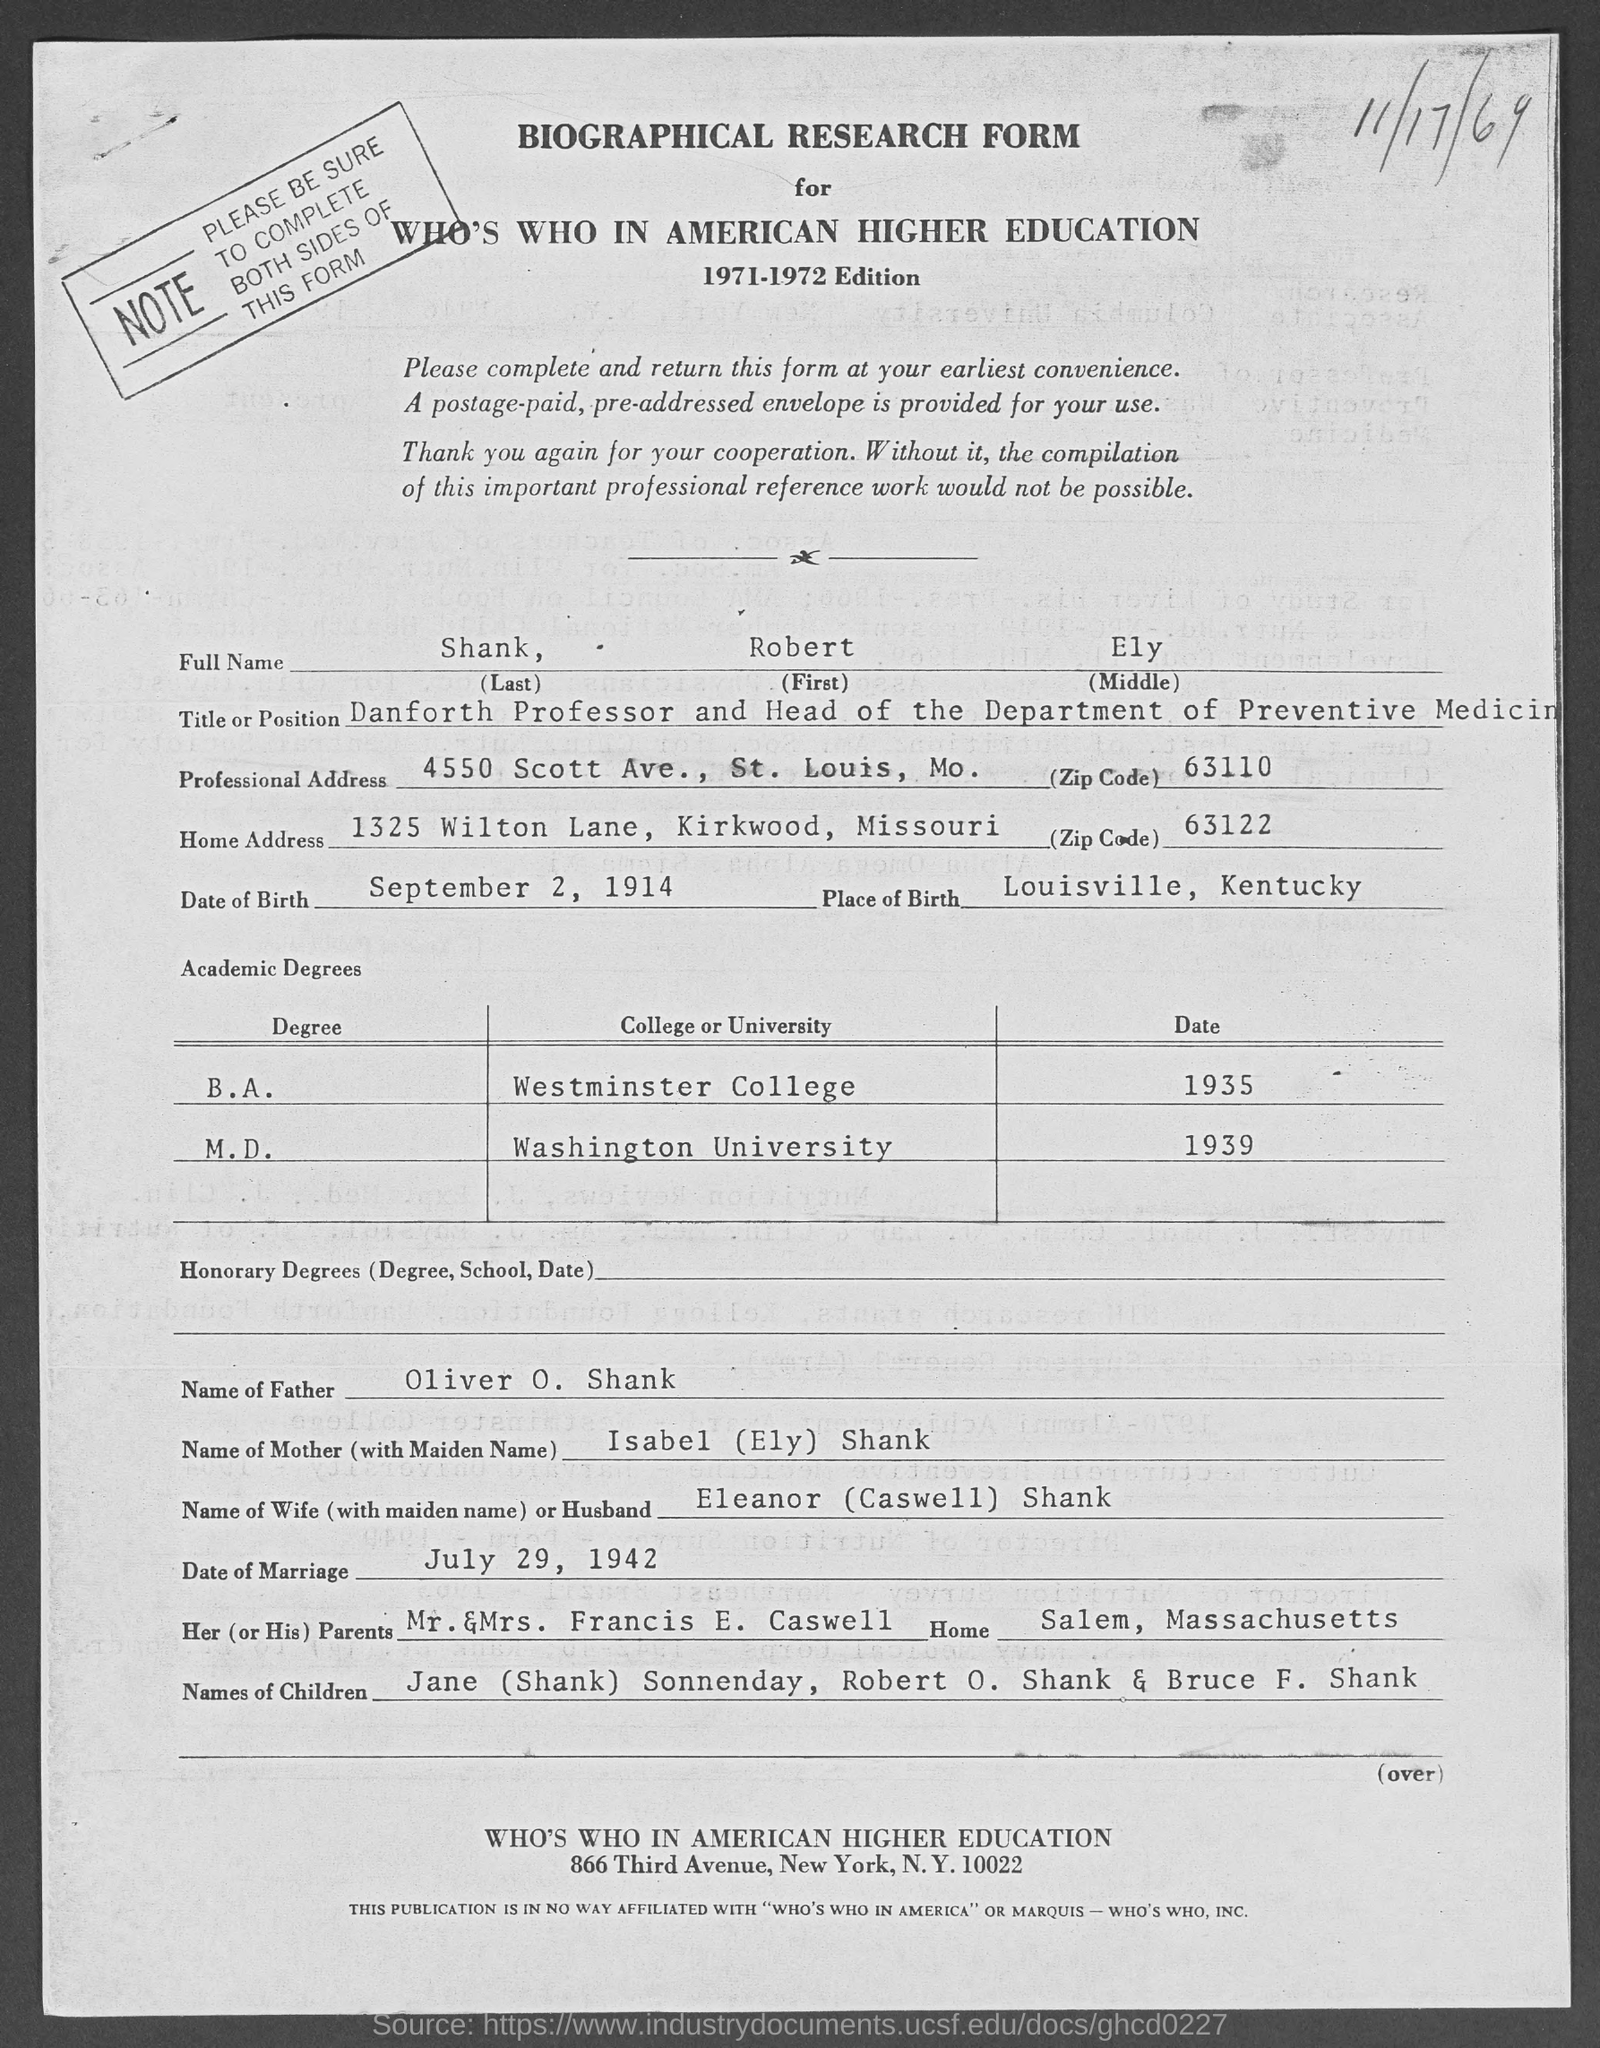Indicate a few pertinent items in this graphic. The given form mentions the title or position of Danforth Professor and Head of the Department of Preventive Medicine. What is the ZIP code for the professional address provided in the given form? The ZIP code is 63110... The last name mentioned in the given form is "Shankar. The given page mentions a form named "biographical research form. Based on the given form, it is not possible to determine the middle name mentioned. 